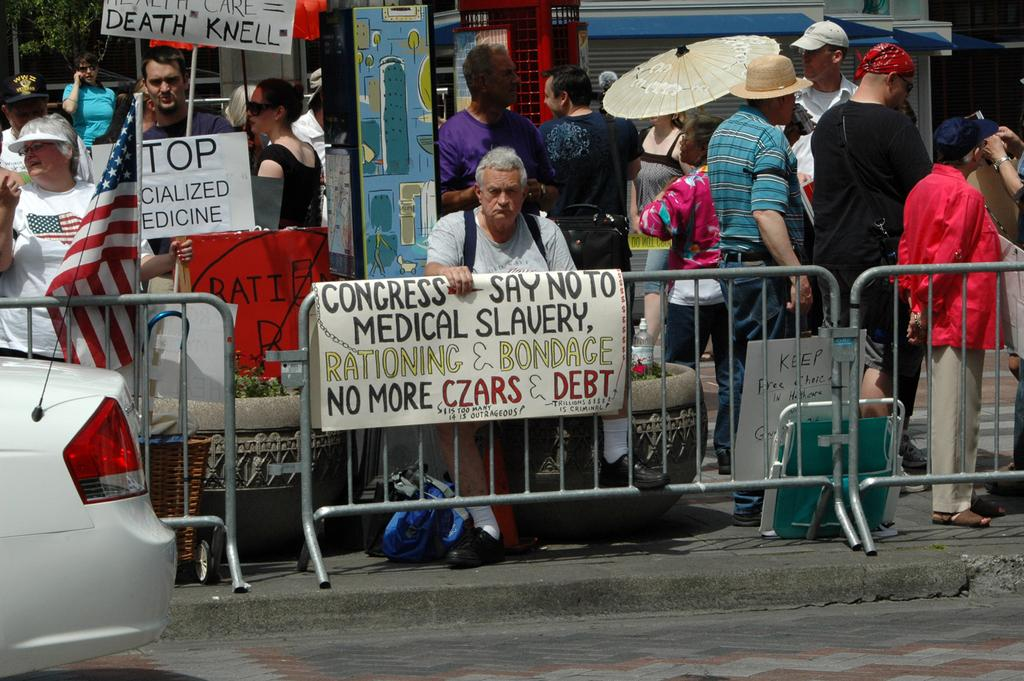What can be seen in the image? There are people standing in the image, along with posters and a white car on the left side. Can you describe the people in the image? The provided facts do not give specific details about the people, so we cannot describe them further. What is the color of the car in the image? The car in the image is white. What type of smile can be seen on the circle in the image? There is no circle or smile present in the image. What discovery was made by the people in the image? The provided facts do not mention any discovery made by the people in the image. 